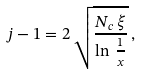<formula> <loc_0><loc_0><loc_500><loc_500>j - 1 = 2 \, \sqrt { \frac { N _ { c } \, \xi } { \ln \, \frac { 1 } { x } } } \, ,</formula> 